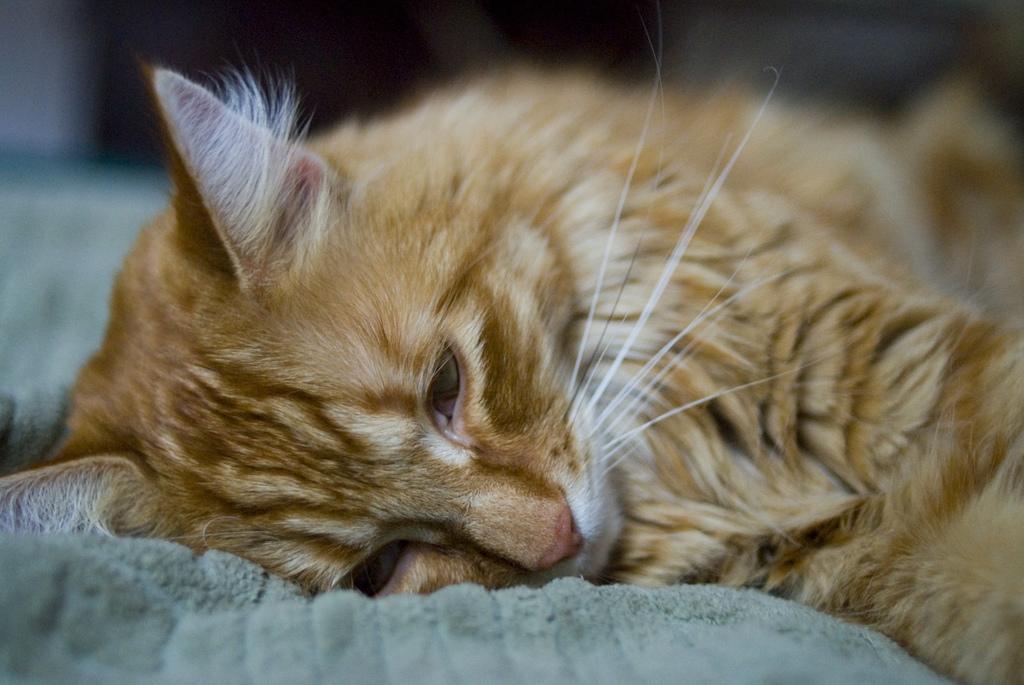How would you summarize this image in a sentence or two? This image is taken indoors. At the bottom of the image there is a towel. On the right side of the image there is a cat lying on the towel. 